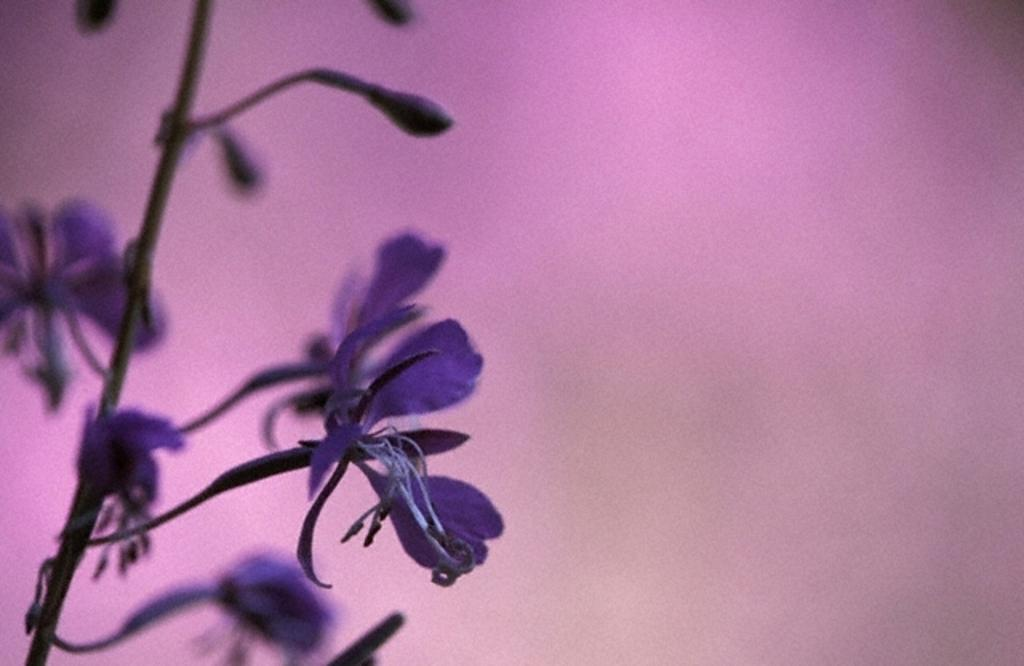What is the main subject of the picture? The main subject of the picture is a flower. Can you describe the color of the flower? The flower is violet in color. What color is the background of the image? The background of the image is pink. How many socks can be seen on the flower in the image? There are no socks present in the image, as it features a flower with a pink background. What advice does the mom give about the flower in the image? There is no mom present in the image, nor is there any advice being given. 